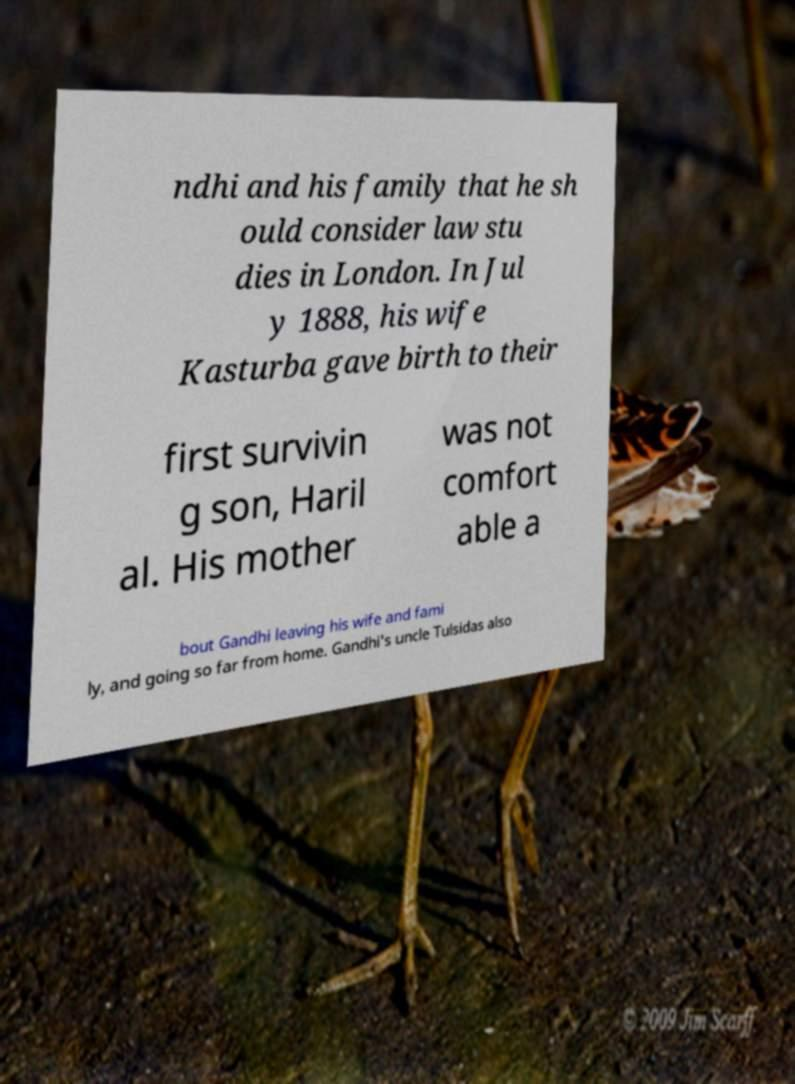What messages or text are displayed in this image? I need them in a readable, typed format. ndhi and his family that he sh ould consider law stu dies in London. In Jul y 1888, his wife Kasturba gave birth to their first survivin g son, Haril al. His mother was not comfort able a bout Gandhi leaving his wife and fami ly, and going so far from home. Gandhi's uncle Tulsidas also 